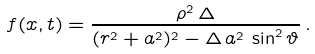Convert formula to latex. <formula><loc_0><loc_0><loc_500><loc_500>f ( x , t ) = \frac { \rho ^ { 2 } \, \Delta } { ( r ^ { 2 } + a ^ { 2 } ) ^ { 2 } - \Delta \, a ^ { 2 } \, \sin ^ { 2 } \vartheta } \, .</formula> 